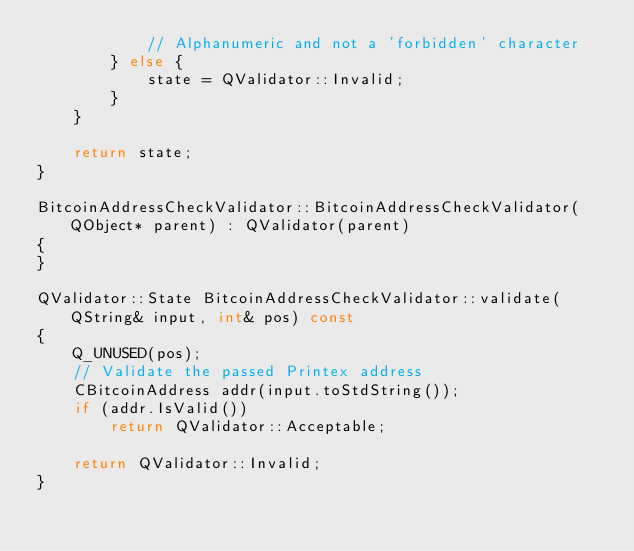Convert code to text. <code><loc_0><loc_0><loc_500><loc_500><_C++_>            // Alphanumeric and not a 'forbidden' character
        } else {
            state = QValidator::Invalid;
        }
    }

    return state;
}

BitcoinAddressCheckValidator::BitcoinAddressCheckValidator(QObject* parent) : QValidator(parent)
{
}

QValidator::State BitcoinAddressCheckValidator::validate(QString& input, int& pos) const
{
    Q_UNUSED(pos);
    // Validate the passed Printex address
    CBitcoinAddress addr(input.toStdString());
    if (addr.IsValid())
        return QValidator::Acceptable;

    return QValidator::Invalid;
}
</code> 